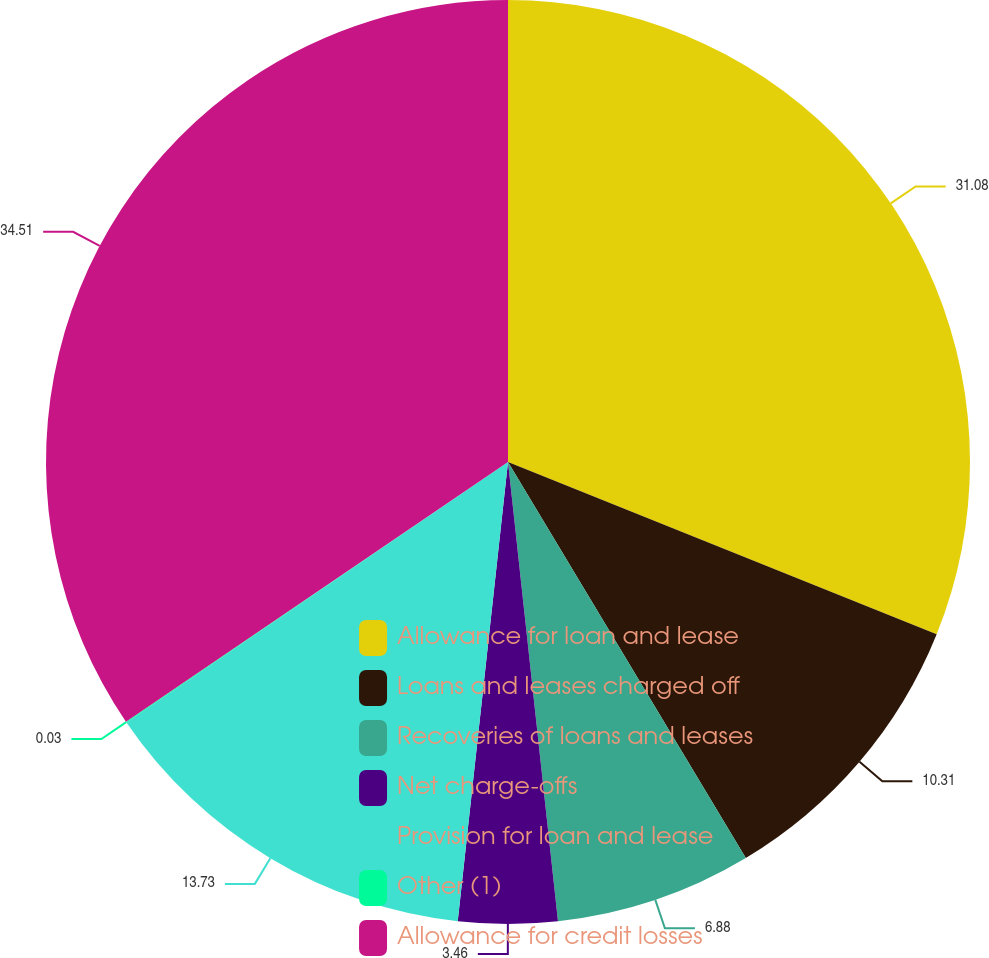Convert chart to OTSL. <chart><loc_0><loc_0><loc_500><loc_500><pie_chart><fcel>Allowance for loan and lease<fcel>Loans and leases charged off<fcel>Recoveries of loans and leases<fcel>Net charge-offs<fcel>Provision for loan and lease<fcel>Other (1)<fcel>Allowance for credit losses<nl><fcel>31.08%<fcel>10.31%<fcel>6.88%<fcel>3.46%<fcel>13.73%<fcel>0.03%<fcel>34.5%<nl></chart> 